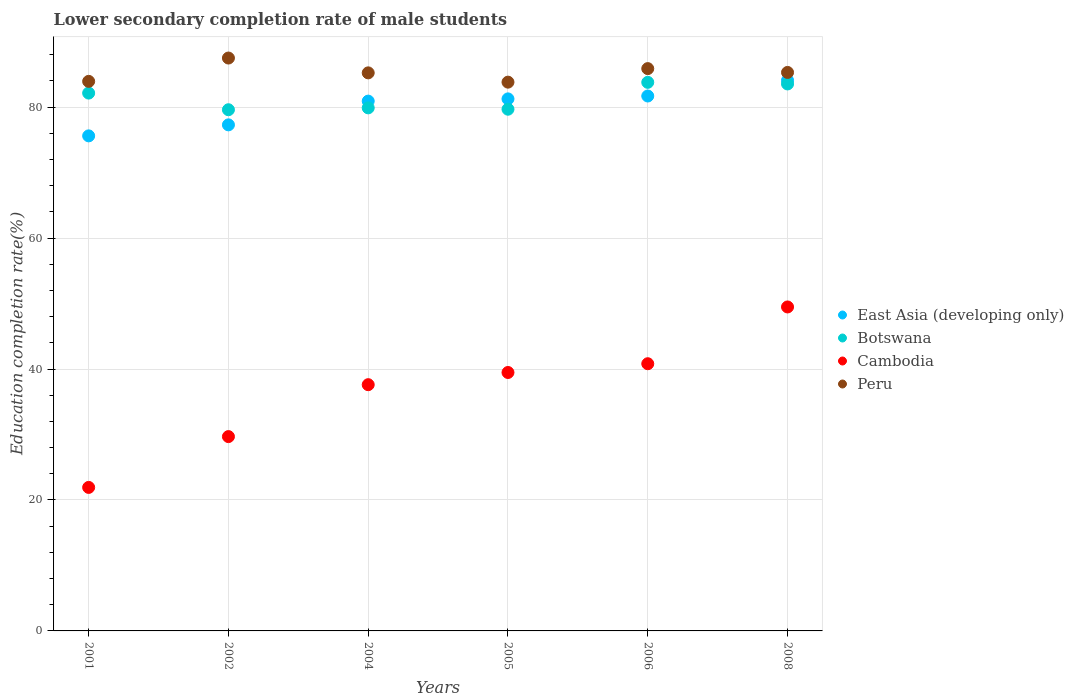What is the lower secondary completion rate of male students in Cambodia in 2002?
Provide a short and direct response. 29.68. Across all years, what is the maximum lower secondary completion rate of male students in East Asia (developing only)?
Make the answer very short. 84.09. Across all years, what is the minimum lower secondary completion rate of male students in Cambodia?
Provide a short and direct response. 21.92. In which year was the lower secondary completion rate of male students in Peru minimum?
Your response must be concise. 2005. What is the total lower secondary completion rate of male students in Peru in the graph?
Your answer should be very brief. 511.65. What is the difference between the lower secondary completion rate of male students in Peru in 2004 and that in 2008?
Your response must be concise. -0.07. What is the difference between the lower secondary completion rate of male students in Botswana in 2002 and the lower secondary completion rate of male students in Peru in 2001?
Provide a succinct answer. -4.33. What is the average lower secondary completion rate of male students in Cambodia per year?
Give a very brief answer. 36.49. In the year 2002, what is the difference between the lower secondary completion rate of male students in Peru and lower secondary completion rate of male students in Cambodia?
Make the answer very short. 57.82. What is the ratio of the lower secondary completion rate of male students in Botswana in 2001 to that in 2005?
Your answer should be very brief. 1.03. Is the lower secondary completion rate of male students in Cambodia in 2002 less than that in 2006?
Give a very brief answer. Yes. Is the difference between the lower secondary completion rate of male students in Peru in 2005 and 2008 greater than the difference between the lower secondary completion rate of male students in Cambodia in 2005 and 2008?
Keep it short and to the point. Yes. What is the difference between the highest and the second highest lower secondary completion rate of male students in Botswana?
Ensure brevity in your answer.  0.25. What is the difference between the highest and the lowest lower secondary completion rate of male students in Cambodia?
Provide a succinct answer. 27.56. In how many years, is the lower secondary completion rate of male students in Botswana greater than the average lower secondary completion rate of male students in Botswana taken over all years?
Give a very brief answer. 3. Is the sum of the lower secondary completion rate of male students in Peru in 2004 and 2005 greater than the maximum lower secondary completion rate of male students in Cambodia across all years?
Provide a short and direct response. Yes. Is the lower secondary completion rate of male students in Peru strictly greater than the lower secondary completion rate of male students in Botswana over the years?
Offer a very short reply. Yes. Is the lower secondary completion rate of male students in Cambodia strictly less than the lower secondary completion rate of male students in East Asia (developing only) over the years?
Keep it short and to the point. Yes. How many dotlines are there?
Give a very brief answer. 4. Are the values on the major ticks of Y-axis written in scientific E-notation?
Give a very brief answer. No. Does the graph contain any zero values?
Give a very brief answer. No. Does the graph contain grids?
Give a very brief answer. Yes. How many legend labels are there?
Your answer should be compact. 4. What is the title of the graph?
Provide a succinct answer. Lower secondary completion rate of male students. What is the label or title of the Y-axis?
Your response must be concise. Education completion rate(%). What is the Education completion rate(%) in East Asia (developing only) in 2001?
Your answer should be compact. 75.61. What is the Education completion rate(%) in Botswana in 2001?
Your response must be concise. 82.14. What is the Education completion rate(%) of Cambodia in 2001?
Give a very brief answer. 21.92. What is the Education completion rate(%) of Peru in 2001?
Ensure brevity in your answer.  83.93. What is the Education completion rate(%) in East Asia (developing only) in 2002?
Ensure brevity in your answer.  77.29. What is the Education completion rate(%) of Botswana in 2002?
Keep it short and to the point. 79.6. What is the Education completion rate(%) in Cambodia in 2002?
Your answer should be compact. 29.68. What is the Education completion rate(%) in Peru in 2002?
Ensure brevity in your answer.  87.49. What is the Education completion rate(%) in East Asia (developing only) in 2004?
Keep it short and to the point. 80.92. What is the Education completion rate(%) of Botswana in 2004?
Your answer should be very brief. 79.89. What is the Education completion rate(%) of Cambodia in 2004?
Offer a terse response. 37.61. What is the Education completion rate(%) in Peru in 2004?
Offer a very short reply. 85.23. What is the Education completion rate(%) of East Asia (developing only) in 2005?
Your response must be concise. 81.26. What is the Education completion rate(%) in Botswana in 2005?
Provide a succinct answer. 79.68. What is the Education completion rate(%) in Cambodia in 2005?
Ensure brevity in your answer.  39.47. What is the Education completion rate(%) in Peru in 2005?
Make the answer very short. 83.81. What is the Education completion rate(%) in East Asia (developing only) in 2006?
Offer a very short reply. 81.7. What is the Education completion rate(%) of Botswana in 2006?
Your response must be concise. 83.78. What is the Education completion rate(%) in Cambodia in 2006?
Provide a short and direct response. 40.81. What is the Education completion rate(%) in Peru in 2006?
Offer a very short reply. 85.88. What is the Education completion rate(%) of East Asia (developing only) in 2008?
Make the answer very short. 84.09. What is the Education completion rate(%) in Botswana in 2008?
Provide a succinct answer. 83.54. What is the Education completion rate(%) in Cambodia in 2008?
Your answer should be very brief. 49.48. What is the Education completion rate(%) of Peru in 2008?
Give a very brief answer. 85.3. Across all years, what is the maximum Education completion rate(%) of East Asia (developing only)?
Provide a succinct answer. 84.09. Across all years, what is the maximum Education completion rate(%) in Botswana?
Provide a succinct answer. 83.78. Across all years, what is the maximum Education completion rate(%) of Cambodia?
Keep it short and to the point. 49.48. Across all years, what is the maximum Education completion rate(%) of Peru?
Ensure brevity in your answer.  87.49. Across all years, what is the minimum Education completion rate(%) in East Asia (developing only)?
Your response must be concise. 75.61. Across all years, what is the minimum Education completion rate(%) of Botswana?
Ensure brevity in your answer.  79.6. Across all years, what is the minimum Education completion rate(%) in Cambodia?
Ensure brevity in your answer.  21.92. Across all years, what is the minimum Education completion rate(%) of Peru?
Your response must be concise. 83.81. What is the total Education completion rate(%) in East Asia (developing only) in the graph?
Provide a short and direct response. 480.85. What is the total Education completion rate(%) in Botswana in the graph?
Give a very brief answer. 488.63. What is the total Education completion rate(%) of Cambodia in the graph?
Your response must be concise. 218.96. What is the total Education completion rate(%) in Peru in the graph?
Keep it short and to the point. 511.65. What is the difference between the Education completion rate(%) of East Asia (developing only) in 2001 and that in 2002?
Your answer should be compact. -1.68. What is the difference between the Education completion rate(%) in Botswana in 2001 and that in 2002?
Offer a very short reply. 2.54. What is the difference between the Education completion rate(%) of Cambodia in 2001 and that in 2002?
Provide a short and direct response. -7.76. What is the difference between the Education completion rate(%) in Peru in 2001 and that in 2002?
Your answer should be very brief. -3.56. What is the difference between the Education completion rate(%) of East Asia (developing only) in 2001 and that in 2004?
Make the answer very short. -5.31. What is the difference between the Education completion rate(%) in Botswana in 2001 and that in 2004?
Make the answer very short. 2.26. What is the difference between the Education completion rate(%) of Cambodia in 2001 and that in 2004?
Your answer should be very brief. -15.69. What is the difference between the Education completion rate(%) in Peru in 2001 and that in 2004?
Make the answer very short. -1.3. What is the difference between the Education completion rate(%) in East Asia (developing only) in 2001 and that in 2005?
Provide a succinct answer. -5.65. What is the difference between the Education completion rate(%) of Botswana in 2001 and that in 2005?
Your answer should be compact. 2.46. What is the difference between the Education completion rate(%) in Cambodia in 2001 and that in 2005?
Give a very brief answer. -17.55. What is the difference between the Education completion rate(%) of Peru in 2001 and that in 2005?
Offer a terse response. 0.12. What is the difference between the Education completion rate(%) in East Asia (developing only) in 2001 and that in 2006?
Keep it short and to the point. -6.09. What is the difference between the Education completion rate(%) in Botswana in 2001 and that in 2006?
Offer a terse response. -1.64. What is the difference between the Education completion rate(%) in Cambodia in 2001 and that in 2006?
Offer a very short reply. -18.89. What is the difference between the Education completion rate(%) of Peru in 2001 and that in 2006?
Ensure brevity in your answer.  -1.95. What is the difference between the Education completion rate(%) of East Asia (developing only) in 2001 and that in 2008?
Offer a terse response. -8.48. What is the difference between the Education completion rate(%) in Botswana in 2001 and that in 2008?
Give a very brief answer. -1.39. What is the difference between the Education completion rate(%) of Cambodia in 2001 and that in 2008?
Offer a terse response. -27.56. What is the difference between the Education completion rate(%) of Peru in 2001 and that in 2008?
Ensure brevity in your answer.  -1.36. What is the difference between the Education completion rate(%) of East Asia (developing only) in 2002 and that in 2004?
Give a very brief answer. -3.63. What is the difference between the Education completion rate(%) of Botswana in 2002 and that in 2004?
Offer a terse response. -0.29. What is the difference between the Education completion rate(%) of Cambodia in 2002 and that in 2004?
Keep it short and to the point. -7.93. What is the difference between the Education completion rate(%) in Peru in 2002 and that in 2004?
Give a very brief answer. 2.26. What is the difference between the Education completion rate(%) in East Asia (developing only) in 2002 and that in 2005?
Your response must be concise. -3.97. What is the difference between the Education completion rate(%) of Botswana in 2002 and that in 2005?
Your response must be concise. -0.08. What is the difference between the Education completion rate(%) in Cambodia in 2002 and that in 2005?
Ensure brevity in your answer.  -9.79. What is the difference between the Education completion rate(%) in Peru in 2002 and that in 2005?
Ensure brevity in your answer.  3.68. What is the difference between the Education completion rate(%) of East Asia (developing only) in 2002 and that in 2006?
Provide a short and direct response. -4.41. What is the difference between the Education completion rate(%) in Botswana in 2002 and that in 2006?
Keep it short and to the point. -4.18. What is the difference between the Education completion rate(%) of Cambodia in 2002 and that in 2006?
Your response must be concise. -11.13. What is the difference between the Education completion rate(%) in Peru in 2002 and that in 2006?
Make the answer very short. 1.61. What is the difference between the Education completion rate(%) in East Asia (developing only) in 2002 and that in 2008?
Provide a succinct answer. -6.8. What is the difference between the Education completion rate(%) in Botswana in 2002 and that in 2008?
Keep it short and to the point. -3.94. What is the difference between the Education completion rate(%) of Cambodia in 2002 and that in 2008?
Give a very brief answer. -19.8. What is the difference between the Education completion rate(%) in Peru in 2002 and that in 2008?
Make the answer very short. 2.2. What is the difference between the Education completion rate(%) in East Asia (developing only) in 2004 and that in 2005?
Your response must be concise. -0.34. What is the difference between the Education completion rate(%) in Botswana in 2004 and that in 2005?
Ensure brevity in your answer.  0.21. What is the difference between the Education completion rate(%) in Cambodia in 2004 and that in 2005?
Your answer should be compact. -1.86. What is the difference between the Education completion rate(%) of Peru in 2004 and that in 2005?
Ensure brevity in your answer.  1.42. What is the difference between the Education completion rate(%) in East Asia (developing only) in 2004 and that in 2006?
Offer a very short reply. -0.78. What is the difference between the Education completion rate(%) in Botswana in 2004 and that in 2006?
Give a very brief answer. -3.9. What is the difference between the Education completion rate(%) in Cambodia in 2004 and that in 2006?
Provide a succinct answer. -3.2. What is the difference between the Education completion rate(%) in Peru in 2004 and that in 2006?
Provide a succinct answer. -0.65. What is the difference between the Education completion rate(%) in East Asia (developing only) in 2004 and that in 2008?
Provide a succinct answer. -3.17. What is the difference between the Education completion rate(%) of Botswana in 2004 and that in 2008?
Your answer should be compact. -3.65. What is the difference between the Education completion rate(%) of Cambodia in 2004 and that in 2008?
Your answer should be compact. -11.87. What is the difference between the Education completion rate(%) of Peru in 2004 and that in 2008?
Ensure brevity in your answer.  -0.07. What is the difference between the Education completion rate(%) of East Asia (developing only) in 2005 and that in 2006?
Your answer should be very brief. -0.44. What is the difference between the Education completion rate(%) of Botswana in 2005 and that in 2006?
Your response must be concise. -4.1. What is the difference between the Education completion rate(%) of Cambodia in 2005 and that in 2006?
Ensure brevity in your answer.  -1.34. What is the difference between the Education completion rate(%) of Peru in 2005 and that in 2006?
Your answer should be compact. -2.07. What is the difference between the Education completion rate(%) of East Asia (developing only) in 2005 and that in 2008?
Provide a short and direct response. -2.83. What is the difference between the Education completion rate(%) of Botswana in 2005 and that in 2008?
Ensure brevity in your answer.  -3.86. What is the difference between the Education completion rate(%) in Cambodia in 2005 and that in 2008?
Provide a short and direct response. -10.01. What is the difference between the Education completion rate(%) in Peru in 2005 and that in 2008?
Make the answer very short. -1.49. What is the difference between the Education completion rate(%) of East Asia (developing only) in 2006 and that in 2008?
Your answer should be compact. -2.39. What is the difference between the Education completion rate(%) in Botswana in 2006 and that in 2008?
Your answer should be compact. 0.25. What is the difference between the Education completion rate(%) in Cambodia in 2006 and that in 2008?
Ensure brevity in your answer.  -8.67. What is the difference between the Education completion rate(%) in Peru in 2006 and that in 2008?
Your answer should be compact. 0.58. What is the difference between the Education completion rate(%) in East Asia (developing only) in 2001 and the Education completion rate(%) in Botswana in 2002?
Give a very brief answer. -3.99. What is the difference between the Education completion rate(%) of East Asia (developing only) in 2001 and the Education completion rate(%) of Cambodia in 2002?
Your response must be concise. 45.93. What is the difference between the Education completion rate(%) of East Asia (developing only) in 2001 and the Education completion rate(%) of Peru in 2002?
Offer a terse response. -11.89. What is the difference between the Education completion rate(%) in Botswana in 2001 and the Education completion rate(%) in Cambodia in 2002?
Keep it short and to the point. 52.46. What is the difference between the Education completion rate(%) in Botswana in 2001 and the Education completion rate(%) in Peru in 2002?
Keep it short and to the point. -5.35. What is the difference between the Education completion rate(%) in Cambodia in 2001 and the Education completion rate(%) in Peru in 2002?
Offer a very short reply. -65.58. What is the difference between the Education completion rate(%) of East Asia (developing only) in 2001 and the Education completion rate(%) of Botswana in 2004?
Make the answer very short. -4.28. What is the difference between the Education completion rate(%) of East Asia (developing only) in 2001 and the Education completion rate(%) of Peru in 2004?
Your answer should be compact. -9.62. What is the difference between the Education completion rate(%) of Botswana in 2001 and the Education completion rate(%) of Cambodia in 2004?
Your response must be concise. 44.53. What is the difference between the Education completion rate(%) in Botswana in 2001 and the Education completion rate(%) in Peru in 2004?
Provide a succinct answer. -3.09. What is the difference between the Education completion rate(%) in Cambodia in 2001 and the Education completion rate(%) in Peru in 2004?
Offer a terse response. -63.31. What is the difference between the Education completion rate(%) in East Asia (developing only) in 2001 and the Education completion rate(%) in Botswana in 2005?
Provide a short and direct response. -4.07. What is the difference between the Education completion rate(%) of East Asia (developing only) in 2001 and the Education completion rate(%) of Cambodia in 2005?
Provide a succinct answer. 36.14. What is the difference between the Education completion rate(%) of East Asia (developing only) in 2001 and the Education completion rate(%) of Peru in 2005?
Your response must be concise. -8.2. What is the difference between the Education completion rate(%) of Botswana in 2001 and the Education completion rate(%) of Cambodia in 2005?
Ensure brevity in your answer.  42.67. What is the difference between the Education completion rate(%) of Botswana in 2001 and the Education completion rate(%) of Peru in 2005?
Make the answer very short. -1.67. What is the difference between the Education completion rate(%) of Cambodia in 2001 and the Education completion rate(%) of Peru in 2005?
Offer a terse response. -61.89. What is the difference between the Education completion rate(%) of East Asia (developing only) in 2001 and the Education completion rate(%) of Botswana in 2006?
Your response must be concise. -8.18. What is the difference between the Education completion rate(%) of East Asia (developing only) in 2001 and the Education completion rate(%) of Cambodia in 2006?
Ensure brevity in your answer.  34.8. What is the difference between the Education completion rate(%) of East Asia (developing only) in 2001 and the Education completion rate(%) of Peru in 2006?
Provide a succinct answer. -10.27. What is the difference between the Education completion rate(%) of Botswana in 2001 and the Education completion rate(%) of Cambodia in 2006?
Offer a very short reply. 41.33. What is the difference between the Education completion rate(%) of Botswana in 2001 and the Education completion rate(%) of Peru in 2006?
Your answer should be compact. -3.74. What is the difference between the Education completion rate(%) in Cambodia in 2001 and the Education completion rate(%) in Peru in 2006?
Your answer should be very brief. -63.96. What is the difference between the Education completion rate(%) in East Asia (developing only) in 2001 and the Education completion rate(%) in Botswana in 2008?
Offer a terse response. -7.93. What is the difference between the Education completion rate(%) in East Asia (developing only) in 2001 and the Education completion rate(%) in Cambodia in 2008?
Offer a terse response. 26.13. What is the difference between the Education completion rate(%) of East Asia (developing only) in 2001 and the Education completion rate(%) of Peru in 2008?
Ensure brevity in your answer.  -9.69. What is the difference between the Education completion rate(%) of Botswana in 2001 and the Education completion rate(%) of Cambodia in 2008?
Your response must be concise. 32.66. What is the difference between the Education completion rate(%) of Botswana in 2001 and the Education completion rate(%) of Peru in 2008?
Make the answer very short. -3.16. What is the difference between the Education completion rate(%) of Cambodia in 2001 and the Education completion rate(%) of Peru in 2008?
Provide a succinct answer. -63.38. What is the difference between the Education completion rate(%) of East Asia (developing only) in 2002 and the Education completion rate(%) of Botswana in 2004?
Provide a short and direct response. -2.6. What is the difference between the Education completion rate(%) in East Asia (developing only) in 2002 and the Education completion rate(%) in Cambodia in 2004?
Keep it short and to the point. 39.68. What is the difference between the Education completion rate(%) of East Asia (developing only) in 2002 and the Education completion rate(%) of Peru in 2004?
Ensure brevity in your answer.  -7.94. What is the difference between the Education completion rate(%) of Botswana in 2002 and the Education completion rate(%) of Cambodia in 2004?
Offer a very short reply. 41.99. What is the difference between the Education completion rate(%) of Botswana in 2002 and the Education completion rate(%) of Peru in 2004?
Provide a short and direct response. -5.63. What is the difference between the Education completion rate(%) in Cambodia in 2002 and the Education completion rate(%) in Peru in 2004?
Provide a succinct answer. -55.55. What is the difference between the Education completion rate(%) in East Asia (developing only) in 2002 and the Education completion rate(%) in Botswana in 2005?
Your answer should be compact. -2.39. What is the difference between the Education completion rate(%) in East Asia (developing only) in 2002 and the Education completion rate(%) in Cambodia in 2005?
Offer a very short reply. 37.82. What is the difference between the Education completion rate(%) of East Asia (developing only) in 2002 and the Education completion rate(%) of Peru in 2005?
Your answer should be very brief. -6.52. What is the difference between the Education completion rate(%) in Botswana in 2002 and the Education completion rate(%) in Cambodia in 2005?
Make the answer very short. 40.13. What is the difference between the Education completion rate(%) of Botswana in 2002 and the Education completion rate(%) of Peru in 2005?
Your answer should be very brief. -4.21. What is the difference between the Education completion rate(%) of Cambodia in 2002 and the Education completion rate(%) of Peru in 2005?
Provide a short and direct response. -54.13. What is the difference between the Education completion rate(%) of East Asia (developing only) in 2002 and the Education completion rate(%) of Botswana in 2006?
Make the answer very short. -6.49. What is the difference between the Education completion rate(%) of East Asia (developing only) in 2002 and the Education completion rate(%) of Cambodia in 2006?
Your answer should be very brief. 36.48. What is the difference between the Education completion rate(%) in East Asia (developing only) in 2002 and the Education completion rate(%) in Peru in 2006?
Your answer should be very brief. -8.59. What is the difference between the Education completion rate(%) of Botswana in 2002 and the Education completion rate(%) of Cambodia in 2006?
Your answer should be very brief. 38.79. What is the difference between the Education completion rate(%) in Botswana in 2002 and the Education completion rate(%) in Peru in 2006?
Your response must be concise. -6.28. What is the difference between the Education completion rate(%) in Cambodia in 2002 and the Education completion rate(%) in Peru in 2006?
Ensure brevity in your answer.  -56.2. What is the difference between the Education completion rate(%) in East Asia (developing only) in 2002 and the Education completion rate(%) in Botswana in 2008?
Your answer should be very brief. -6.25. What is the difference between the Education completion rate(%) of East Asia (developing only) in 2002 and the Education completion rate(%) of Cambodia in 2008?
Provide a short and direct response. 27.81. What is the difference between the Education completion rate(%) of East Asia (developing only) in 2002 and the Education completion rate(%) of Peru in 2008?
Keep it short and to the point. -8.01. What is the difference between the Education completion rate(%) in Botswana in 2002 and the Education completion rate(%) in Cambodia in 2008?
Your answer should be compact. 30.12. What is the difference between the Education completion rate(%) of Botswana in 2002 and the Education completion rate(%) of Peru in 2008?
Offer a terse response. -5.7. What is the difference between the Education completion rate(%) in Cambodia in 2002 and the Education completion rate(%) in Peru in 2008?
Give a very brief answer. -55.62. What is the difference between the Education completion rate(%) of East Asia (developing only) in 2004 and the Education completion rate(%) of Botswana in 2005?
Offer a terse response. 1.24. What is the difference between the Education completion rate(%) of East Asia (developing only) in 2004 and the Education completion rate(%) of Cambodia in 2005?
Your response must be concise. 41.45. What is the difference between the Education completion rate(%) in East Asia (developing only) in 2004 and the Education completion rate(%) in Peru in 2005?
Your answer should be very brief. -2.9. What is the difference between the Education completion rate(%) of Botswana in 2004 and the Education completion rate(%) of Cambodia in 2005?
Your answer should be very brief. 40.42. What is the difference between the Education completion rate(%) of Botswana in 2004 and the Education completion rate(%) of Peru in 2005?
Provide a short and direct response. -3.93. What is the difference between the Education completion rate(%) in Cambodia in 2004 and the Education completion rate(%) in Peru in 2005?
Your answer should be compact. -46.2. What is the difference between the Education completion rate(%) in East Asia (developing only) in 2004 and the Education completion rate(%) in Botswana in 2006?
Make the answer very short. -2.87. What is the difference between the Education completion rate(%) of East Asia (developing only) in 2004 and the Education completion rate(%) of Cambodia in 2006?
Offer a terse response. 40.11. What is the difference between the Education completion rate(%) of East Asia (developing only) in 2004 and the Education completion rate(%) of Peru in 2006?
Your answer should be compact. -4.97. What is the difference between the Education completion rate(%) in Botswana in 2004 and the Education completion rate(%) in Cambodia in 2006?
Make the answer very short. 39.08. What is the difference between the Education completion rate(%) in Botswana in 2004 and the Education completion rate(%) in Peru in 2006?
Your answer should be compact. -6. What is the difference between the Education completion rate(%) in Cambodia in 2004 and the Education completion rate(%) in Peru in 2006?
Your answer should be compact. -48.27. What is the difference between the Education completion rate(%) of East Asia (developing only) in 2004 and the Education completion rate(%) of Botswana in 2008?
Keep it short and to the point. -2.62. What is the difference between the Education completion rate(%) in East Asia (developing only) in 2004 and the Education completion rate(%) in Cambodia in 2008?
Your answer should be compact. 31.44. What is the difference between the Education completion rate(%) of East Asia (developing only) in 2004 and the Education completion rate(%) of Peru in 2008?
Your response must be concise. -4.38. What is the difference between the Education completion rate(%) of Botswana in 2004 and the Education completion rate(%) of Cambodia in 2008?
Offer a terse response. 30.41. What is the difference between the Education completion rate(%) in Botswana in 2004 and the Education completion rate(%) in Peru in 2008?
Your answer should be very brief. -5.41. What is the difference between the Education completion rate(%) in Cambodia in 2004 and the Education completion rate(%) in Peru in 2008?
Offer a terse response. -47.69. What is the difference between the Education completion rate(%) in East Asia (developing only) in 2005 and the Education completion rate(%) in Botswana in 2006?
Make the answer very short. -2.53. What is the difference between the Education completion rate(%) of East Asia (developing only) in 2005 and the Education completion rate(%) of Cambodia in 2006?
Your answer should be compact. 40.45. What is the difference between the Education completion rate(%) in East Asia (developing only) in 2005 and the Education completion rate(%) in Peru in 2006?
Provide a succinct answer. -4.62. What is the difference between the Education completion rate(%) of Botswana in 2005 and the Education completion rate(%) of Cambodia in 2006?
Offer a very short reply. 38.87. What is the difference between the Education completion rate(%) of Botswana in 2005 and the Education completion rate(%) of Peru in 2006?
Make the answer very short. -6.2. What is the difference between the Education completion rate(%) in Cambodia in 2005 and the Education completion rate(%) in Peru in 2006?
Your answer should be very brief. -46.41. What is the difference between the Education completion rate(%) of East Asia (developing only) in 2005 and the Education completion rate(%) of Botswana in 2008?
Ensure brevity in your answer.  -2.28. What is the difference between the Education completion rate(%) of East Asia (developing only) in 2005 and the Education completion rate(%) of Cambodia in 2008?
Your answer should be compact. 31.78. What is the difference between the Education completion rate(%) in East Asia (developing only) in 2005 and the Education completion rate(%) in Peru in 2008?
Make the answer very short. -4.04. What is the difference between the Education completion rate(%) in Botswana in 2005 and the Education completion rate(%) in Cambodia in 2008?
Offer a very short reply. 30.2. What is the difference between the Education completion rate(%) in Botswana in 2005 and the Education completion rate(%) in Peru in 2008?
Your answer should be very brief. -5.62. What is the difference between the Education completion rate(%) of Cambodia in 2005 and the Education completion rate(%) of Peru in 2008?
Offer a terse response. -45.83. What is the difference between the Education completion rate(%) in East Asia (developing only) in 2006 and the Education completion rate(%) in Botswana in 2008?
Provide a succinct answer. -1.84. What is the difference between the Education completion rate(%) in East Asia (developing only) in 2006 and the Education completion rate(%) in Cambodia in 2008?
Offer a terse response. 32.22. What is the difference between the Education completion rate(%) in East Asia (developing only) in 2006 and the Education completion rate(%) in Peru in 2008?
Offer a very short reply. -3.6. What is the difference between the Education completion rate(%) in Botswana in 2006 and the Education completion rate(%) in Cambodia in 2008?
Give a very brief answer. 34.3. What is the difference between the Education completion rate(%) of Botswana in 2006 and the Education completion rate(%) of Peru in 2008?
Offer a very short reply. -1.51. What is the difference between the Education completion rate(%) of Cambodia in 2006 and the Education completion rate(%) of Peru in 2008?
Keep it short and to the point. -44.49. What is the average Education completion rate(%) in East Asia (developing only) per year?
Give a very brief answer. 80.14. What is the average Education completion rate(%) of Botswana per year?
Provide a succinct answer. 81.44. What is the average Education completion rate(%) of Cambodia per year?
Your answer should be very brief. 36.49. What is the average Education completion rate(%) of Peru per year?
Give a very brief answer. 85.27. In the year 2001, what is the difference between the Education completion rate(%) of East Asia (developing only) and Education completion rate(%) of Botswana?
Provide a succinct answer. -6.53. In the year 2001, what is the difference between the Education completion rate(%) of East Asia (developing only) and Education completion rate(%) of Cambodia?
Offer a very short reply. 53.69. In the year 2001, what is the difference between the Education completion rate(%) in East Asia (developing only) and Education completion rate(%) in Peru?
Ensure brevity in your answer.  -8.33. In the year 2001, what is the difference between the Education completion rate(%) of Botswana and Education completion rate(%) of Cambodia?
Offer a terse response. 60.22. In the year 2001, what is the difference between the Education completion rate(%) of Botswana and Education completion rate(%) of Peru?
Make the answer very short. -1.79. In the year 2001, what is the difference between the Education completion rate(%) in Cambodia and Education completion rate(%) in Peru?
Keep it short and to the point. -62.02. In the year 2002, what is the difference between the Education completion rate(%) in East Asia (developing only) and Education completion rate(%) in Botswana?
Give a very brief answer. -2.31. In the year 2002, what is the difference between the Education completion rate(%) of East Asia (developing only) and Education completion rate(%) of Cambodia?
Your response must be concise. 47.61. In the year 2002, what is the difference between the Education completion rate(%) of East Asia (developing only) and Education completion rate(%) of Peru?
Make the answer very short. -10.2. In the year 2002, what is the difference between the Education completion rate(%) of Botswana and Education completion rate(%) of Cambodia?
Provide a short and direct response. 49.92. In the year 2002, what is the difference between the Education completion rate(%) in Botswana and Education completion rate(%) in Peru?
Provide a succinct answer. -7.9. In the year 2002, what is the difference between the Education completion rate(%) of Cambodia and Education completion rate(%) of Peru?
Provide a short and direct response. -57.82. In the year 2004, what is the difference between the Education completion rate(%) in East Asia (developing only) and Education completion rate(%) in Botswana?
Your answer should be compact. 1.03. In the year 2004, what is the difference between the Education completion rate(%) in East Asia (developing only) and Education completion rate(%) in Cambodia?
Provide a short and direct response. 43.31. In the year 2004, what is the difference between the Education completion rate(%) in East Asia (developing only) and Education completion rate(%) in Peru?
Give a very brief answer. -4.32. In the year 2004, what is the difference between the Education completion rate(%) of Botswana and Education completion rate(%) of Cambodia?
Ensure brevity in your answer.  42.28. In the year 2004, what is the difference between the Education completion rate(%) in Botswana and Education completion rate(%) in Peru?
Offer a terse response. -5.35. In the year 2004, what is the difference between the Education completion rate(%) in Cambodia and Education completion rate(%) in Peru?
Provide a succinct answer. -47.62. In the year 2005, what is the difference between the Education completion rate(%) in East Asia (developing only) and Education completion rate(%) in Botswana?
Your response must be concise. 1.58. In the year 2005, what is the difference between the Education completion rate(%) in East Asia (developing only) and Education completion rate(%) in Cambodia?
Offer a terse response. 41.79. In the year 2005, what is the difference between the Education completion rate(%) of East Asia (developing only) and Education completion rate(%) of Peru?
Your response must be concise. -2.55. In the year 2005, what is the difference between the Education completion rate(%) of Botswana and Education completion rate(%) of Cambodia?
Your answer should be compact. 40.21. In the year 2005, what is the difference between the Education completion rate(%) in Botswana and Education completion rate(%) in Peru?
Your answer should be very brief. -4.13. In the year 2005, what is the difference between the Education completion rate(%) of Cambodia and Education completion rate(%) of Peru?
Provide a short and direct response. -44.34. In the year 2006, what is the difference between the Education completion rate(%) in East Asia (developing only) and Education completion rate(%) in Botswana?
Offer a very short reply. -2.09. In the year 2006, what is the difference between the Education completion rate(%) in East Asia (developing only) and Education completion rate(%) in Cambodia?
Provide a succinct answer. 40.89. In the year 2006, what is the difference between the Education completion rate(%) of East Asia (developing only) and Education completion rate(%) of Peru?
Offer a terse response. -4.18. In the year 2006, what is the difference between the Education completion rate(%) in Botswana and Education completion rate(%) in Cambodia?
Offer a very short reply. 42.98. In the year 2006, what is the difference between the Education completion rate(%) in Botswana and Education completion rate(%) in Peru?
Provide a short and direct response. -2.1. In the year 2006, what is the difference between the Education completion rate(%) in Cambodia and Education completion rate(%) in Peru?
Your response must be concise. -45.07. In the year 2008, what is the difference between the Education completion rate(%) in East Asia (developing only) and Education completion rate(%) in Botswana?
Your answer should be very brief. 0.55. In the year 2008, what is the difference between the Education completion rate(%) of East Asia (developing only) and Education completion rate(%) of Cambodia?
Provide a succinct answer. 34.61. In the year 2008, what is the difference between the Education completion rate(%) in East Asia (developing only) and Education completion rate(%) in Peru?
Your answer should be compact. -1.21. In the year 2008, what is the difference between the Education completion rate(%) in Botswana and Education completion rate(%) in Cambodia?
Provide a short and direct response. 34.06. In the year 2008, what is the difference between the Education completion rate(%) in Botswana and Education completion rate(%) in Peru?
Offer a terse response. -1.76. In the year 2008, what is the difference between the Education completion rate(%) of Cambodia and Education completion rate(%) of Peru?
Your response must be concise. -35.82. What is the ratio of the Education completion rate(%) of East Asia (developing only) in 2001 to that in 2002?
Offer a very short reply. 0.98. What is the ratio of the Education completion rate(%) of Botswana in 2001 to that in 2002?
Your answer should be very brief. 1.03. What is the ratio of the Education completion rate(%) in Cambodia in 2001 to that in 2002?
Offer a very short reply. 0.74. What is the ratio of the Education completion rate(%) in Peru in 2001 to that in 2002?
Your answer should be compact. 0.96. What is the ratio of the Education completion rate(%) of East Asia (developing only) in 2001 to that in 2004?
Offer a very short reply. 0.93. What is the ratio of the Education completion rate(%) of Botswana in 2001 to that in 2004?
Give a very brief answer. 1.03. What is the ratio of the Education completion rate(%) of Cambodia in 2001 to that in 2004?
Make the answer very short. 0.58. What is the ratio of the Education completion rate(%) in East Asia (developing only) in 2001 to that in 2005?
Ensure brevity in your answer.  0.93. What is the ratio of the Education completion rate(%) in Botswana in 2001 to that in 2005?
Keep it short and to the point. 1.03. What is the ratio of the Education completion rate(%) of Cambodia in 2001 to that in 2005?
Make the answer very short. 0.56. What is the ratio of the Education completion rate(%) in East Asia (developing only) in 2001 to that in 2006?
Ensure brevity in your answer.  0.93. What is the ratio of the Education completion rate(%) in Botswana in 2001 to that in 2006?
Provide a short and direct response. 0.98. What is the ratio of the Education completion rate(%) of Cambodia in 2001 to that in 2006?
Provide a short and direct response. 0.54. What is the ratio of the Education completion rate(%) of Peru in 2001 to that in 2006?
Ensure brevity in your answer.  0.98. What is the ratio of the Education completion rate(%) of East Asia (developing only) in 2001 to that in 2008?
Ensure brevity in your answer.  0.9. What is the ratio of the Education completion rate(%) in Botswana in 2001 to that in 2008?
Offer a terse response. 0.98. What is the ratio of the Education completion rate(%) in Cambodia in 2001 to that in 2008?
Provide a succinct answer. 0.44. What is the ratio of the Education completion rate(%) of Peru in 2001 to that in 2008?
Your answer should be compact. 0.98. What is the ratio of the Education completion rate(%) of East Asia (developing only) in 2002 to that in 2004?
Offer a terse response. 0.96. What is the ratio of the Education completion rate(%) of Botswana in 2002 to that in 2004?
Your response must be concise. 1. What is the ratio of the Education completion rate(%) in Cambodia in 2002 to that in 2004?
Offer a very short reply. 0.79. What is the ratio of the Education completion rate(%) in Peru in 2002 to that in 2004?
Make the answer very short. 1.03. What is the ratio of the Education completion rate(%) in East Asia (developing only) in 2002 to that in 2005?
Ensure brevity in your answer.  0.95. What is the ratio of the Education completion rate(%) in Cambodia in 2002 to that in 2005?
Provide a short and direct response. 0.75. What is the ratio of the Education completion rate(%) of Peru in 2002 to that in 2005?
Provide a succinct answer. 1.04. What is the ratio of the Education completion rate(%) of East Asia (developing only) in 2002 to that in 2006?
Ensure brevity in your answer.  0.95. What is the ratio of the Education completion rate(%) of Botswana in 2002 to that in 2006?
Make the answer very short. 0.95. What is the ratio of the Education completion rate(%) of Cambodia in 2002 to that in 2006?
Your answer should be compact. 0.73. What is the ratio of the Education completion rate(%) of Peru in 2002 to that in 2006?
Ensure brevity in your answer.  1.02. What is the ratio of the Education completion rate(%) in East Asia (developing only) in 2002 to that in 2008?
Offer a very short reply. 0.92. What is the ratio of the Education completion rate(%) of Botswana in 2002 to that in 2008?
Ensure brevity in your answer.  0.95. What is the ratio of the Education completion rate(%) of Cambodia in 2002 to that in 2008?
Provide a succinct answer. 0.6. What is the ratio of the Education completion rate(%) in Peru in 2002 to that in 2008?
Keep it short and to the point. 1.03. What is the ratio of the Education completion rate(%) of Cambodia in 2004 to that in 2005?
Give a very brief answer. 0.95. What is the ratio of the Education completion rate(%) of Peru in 2004 to that in 2005?
Your answer should be compact. 1.02. What is the ratio of the Education completion rate(%) in Botswana in 2004 to that in 2006?
Ensure brevity in your answer.  0.95. What is the ratio of the Education completion rate(%) of Cambodia in 2004 to that in 2006?
Offer a terse response. 0.92. What is the ratio of the Education completion rate(%) in Peru in 2004 to that in 2006?
Your answer should be compact. 0.99. What is the ratio of the Education completion rate(%) in East Asia (developing only) in 2004 to that in 2008?
Make the answer very short. 0.96. What is the ratio of the Education completion rate(%) of Botswana in 2004 to that in 2008?
Make the answer very short. 0.96. What is the ratio of the Education completion rate(%) in Cambodia in 2004 to that in 2008?
Make the answer very short. 0.76. What is the ratio of the Education completion rate(%) of Peru in 2004 to that in 2008?
Give a very brief answer. 1. What is the ratio of the Education completion rate(%) in Botswana in 2005 to that in 2006?
Your answer should be compact. 0.95. What is the ratio of the Education completion rate(%) of Cambodia in 2005 to that in 2006?
Keep it short and to the point. 0.97. What is the ratio of the Education completion rate(%) of Peru in 2005 to that in 2006?
Provide a succinct answer. 0.98. What is the ratio of the Education completion rate(%) of East Asia (developing only) in 2005 to that in 2008?
Give a very brief answer. 0.97. What is the ratio of the Education completion rate(%) of Botswana in 2005 to that in 2008?
Offer a very short reply. 0.95. What is the ratio of the Education completion rate(%) of Cambodia in 2005 to that in 2008?
Make the answer very short. 0.8. What is the ratio of the Education completion rate(%) of Peru in 2005 to that in 2008?
Provide a succinct answer. 0.98. What is the ratio of the Education completion rate(%) of East Asia (developing only) in 2006 to that in 2008?
Your response must be concise. 0.97. What is the ratio of the Education completion rate(%) in Cambodia in 2006 to that in 2008?
Ensure brevity in your answer.  0.82. What is the ratio of the Education completion rate(%) in Peru in 2006 to that in 2008?
Provide a short and direct response. 1.01. What is the difference between the highest and the second highest Education completion rate(%) of East Asia (developing only)?
Give a very brief answer. 2.39. What is the difference between the highest and the second highest Education completion rate(%) in Botswana?
Provide a succinct answer. 0.25. What is the difference between the highest and the second highest Education completion rate(%) in Cambodia?
Your answer should be very brief. 8.67. What is the difference between the highest and the second highest Education completion rate(%) of Peru?
Give a very brief answer. 1.61. What is the difference between the highest and the lowest Education completion rate(%) of East Asia (developing only)?
Offer a terse response. 8.48. What is the difference between the highest and the lowest Education completion rate(%) of Botswana?
Provide a short and direct response. 4.18. What is the difference between the highest and the lowest Education completion rate(%) in Cambodia?
Your answer should be compact. 27.56. What is the difference between the highest and the lowest Education completion rate(%) of Peru?
Give a very brief answer. 3.68. 